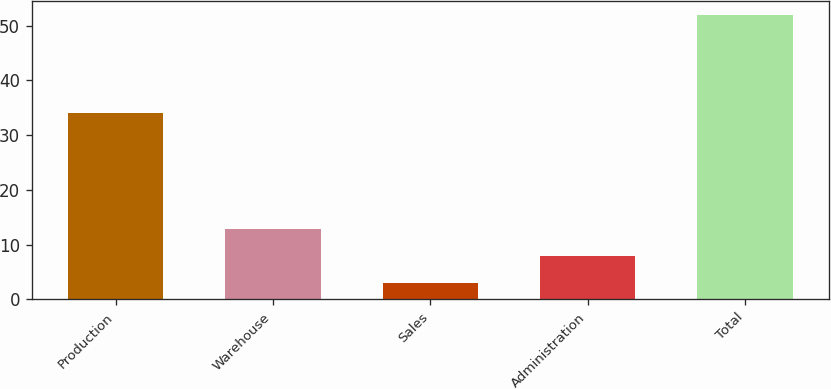<chart> <loc_0><loc_0><loc_500><loc_500><bar_chart><fcel>Production<fcel>Warehouse<fcel>Sales<fcel>Administration<fcel>Total<nl><fcel>34<fcel>12.8<fcel>3<fcel>7.9<fcel>52<nl></chart> 